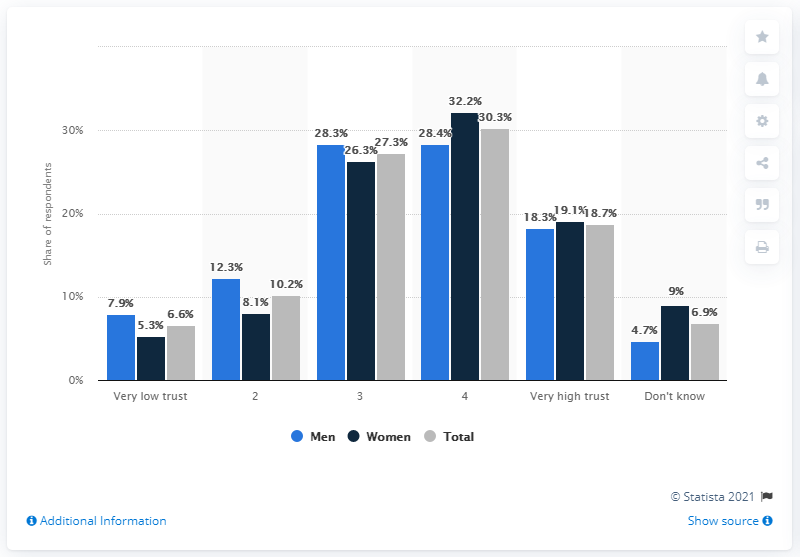Point out several critical features in this image. The question asks for the number that has the tallest bars. The answer is 4. According to the ratings, the greatest value difference between men and women is shown by rating 4. In a survey conducted in Norway, 6.6% of respondents stated that they had very little trust in the political authorities. 